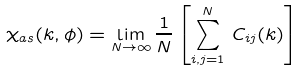Convert formula to latex. <formula><loc_0><loc_0><loc_500><loc_500>\chi _ { a s } ( k , \phi ) = \lim _ { N \to \infty } \frac { 1 } { N } \left [ \sum _ { i , j = 1 } ^ { N } \, C _ { i j } ( k ) \right ]</formula> 